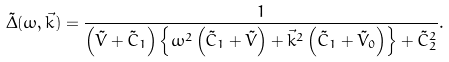Convert formula to latex. <formula><loc_0><loc_0><loc_500><loc_500>\tilde { \Delta } ( \omega , \vec { k } ) = \frac { 1 } { \left ( \tilde { V } + \tilde { C } _ { 1 } \right ) \left \{ \omega ^ { 2 } \left ( \tilde { C } _ { 1 } + \tilde { V } \right ) + \vec { k } ^ { 2 } \left ( \tilde { C } _ { 1 } + \tilde { V } _ { 0 } \right ) \right \} + \tilde { C } _ { 2 } ^ { 2 } } .</formula> 